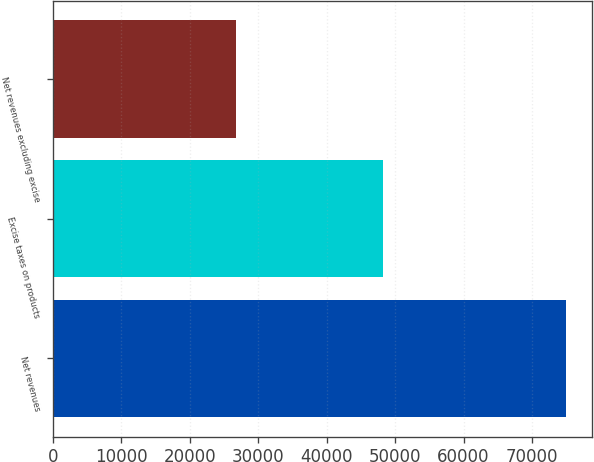Convert chart. <chart><loc_0><loc_0><loc_500><loc_500><bar_chart><fcel>Net revenues<fcel>Excise taxes on products<fcel>Net revenues excluding excise<nl><fcel>74953<fcel>48268<fcel>26685<nl></chart> 